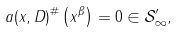Convert formula to latex. <formula><loc_0><loc_0><loc_500><loc_500>a ( x , D ) ^ { \# } \left ( x ^ { \beta } \right ) = 0 \in \mathcal { S } _ { \infty } ^ { \prime } ,</formula> 